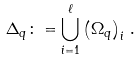Convert formula to latex. <formula><loc_0><loc_0><loc_500><loc_500>\Delta _ { q } \colon = \bigcup _ { i = 1 } ^ { \ell } \left ( \Omega _ { q } \right ) _ { i } \, .</formula> 